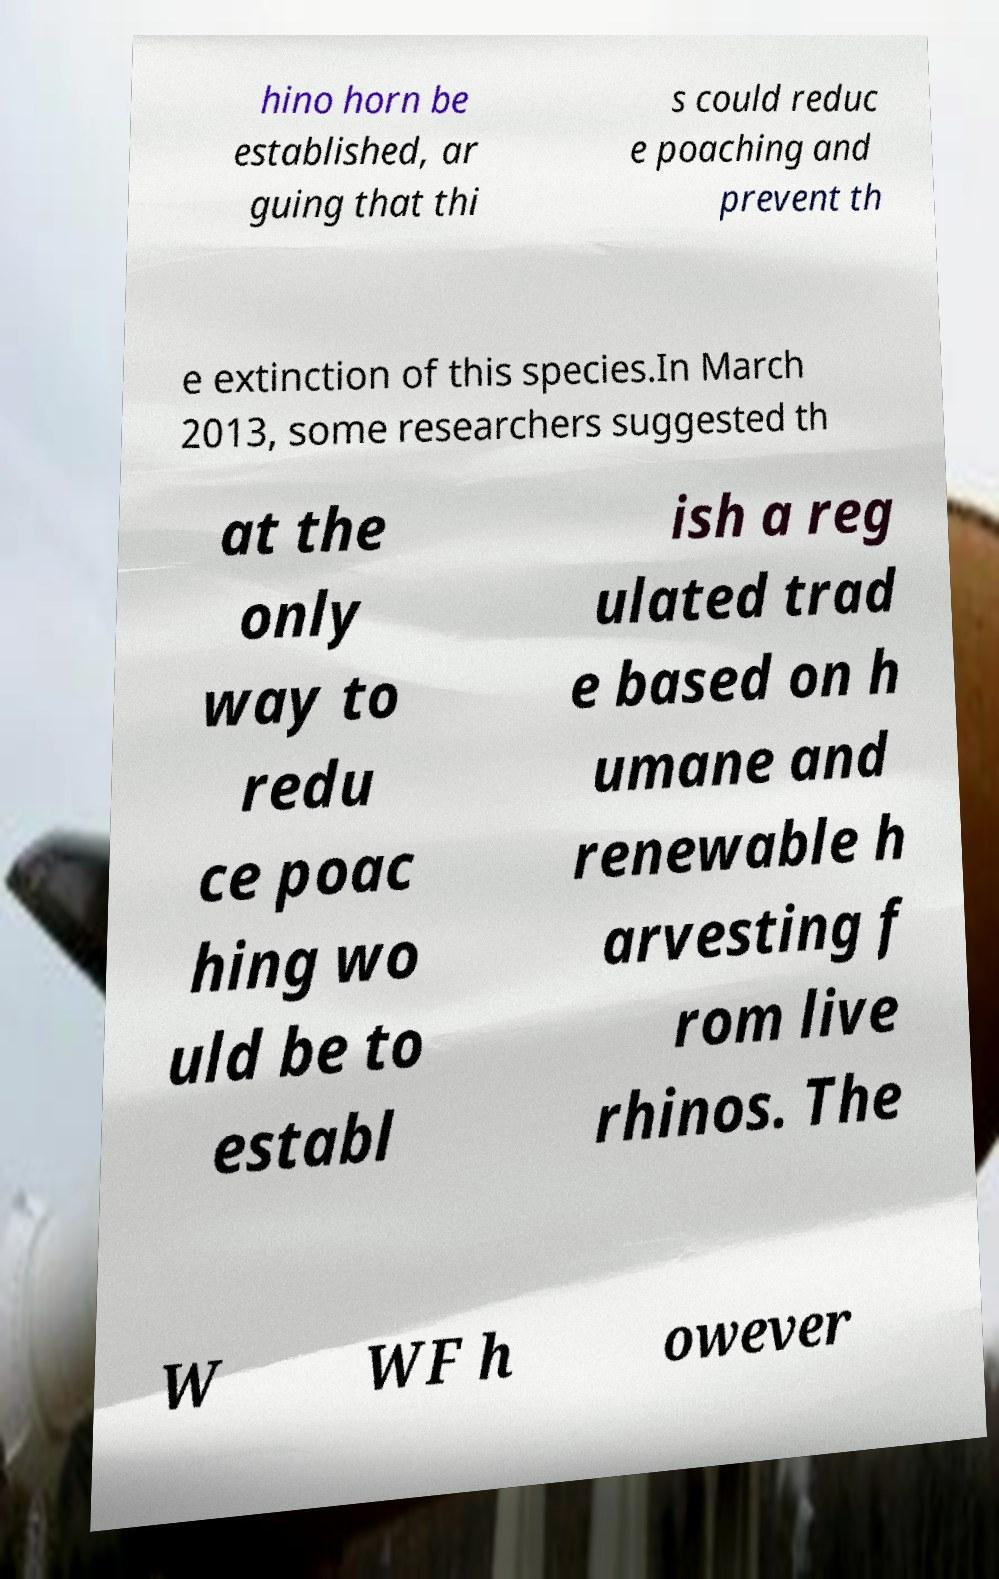Can you read and provide the text displayed in the image?This photo seems to have some interesting text. Can you extract and type it out for me? hino horn be established, ar guing that thi s could reduc e poaching and prevent th e extinction of this species.In March 2013, some researchers suggested th at the only way to redu ce poac hing wo uld be to establ ish a reg ulated trad e based on h umane and renewable h arvesting f rom live rhinos. The W WF h owever 